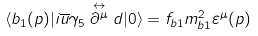Convert formula to latex. <formula><loc_0><loc_0><loc_500><loc_500>\langle b _ { 1 } ( { p } ) | i \overline { u } \gamma _ { 5 } \stackrel { \leftrightarrow } { \partial ^ { \mu } } d | 0 \rangle = f _ { b 1 } m _ { b 1 } ^ { 2 } \varepsilon ^ { \mu } ( p )</formula> 